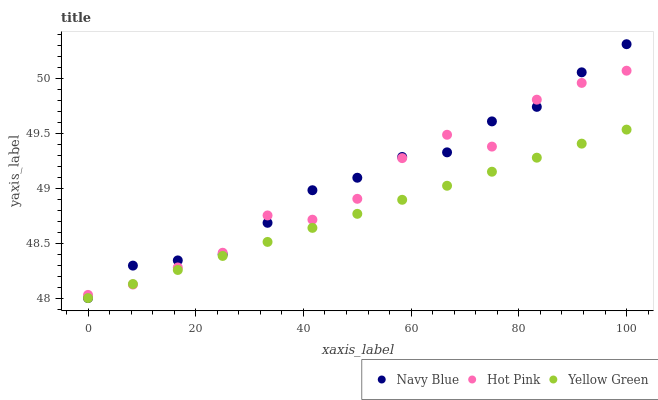Does Yellow Green have the minimum area under the curve?
Answer yes or no. Yes. Does Navy Blue have the maximum area under the curve?
Answer yes or no. Yes. Does Hot Pink have the minimum area under the curve?
Answer yes or no. No. Does Hot Pink have the maximum area under the curve?
Answer yes or no. No. Is Yellow Green the smoothest?
Answer yes or no. Yes. Is Hot Pink the roughest?
Answer yes or no. Yes. Is Hot Pink the smoothest?
Answer yes or no. No. Is Yellow Green the roughest?
Answer yes or no. No. Does Navy Blue have the lowest value?
Answer yes or no. Yes. Does Hot Pink have the lowest value?
Answer yes or no. No. Does Navy Blue have the highest value?
Answer yes or no. Yes. Does Hot Pink have the highest value?
Answer yes or no. No. Does Navy Blue intersect Hot Pink?
Answer yes or no. Yes. Is Navy Blue less than Hot Pink?
Answer yes or no. No. Is Navy Blue greater than Hot Pink?
Answer yes or no. No. 